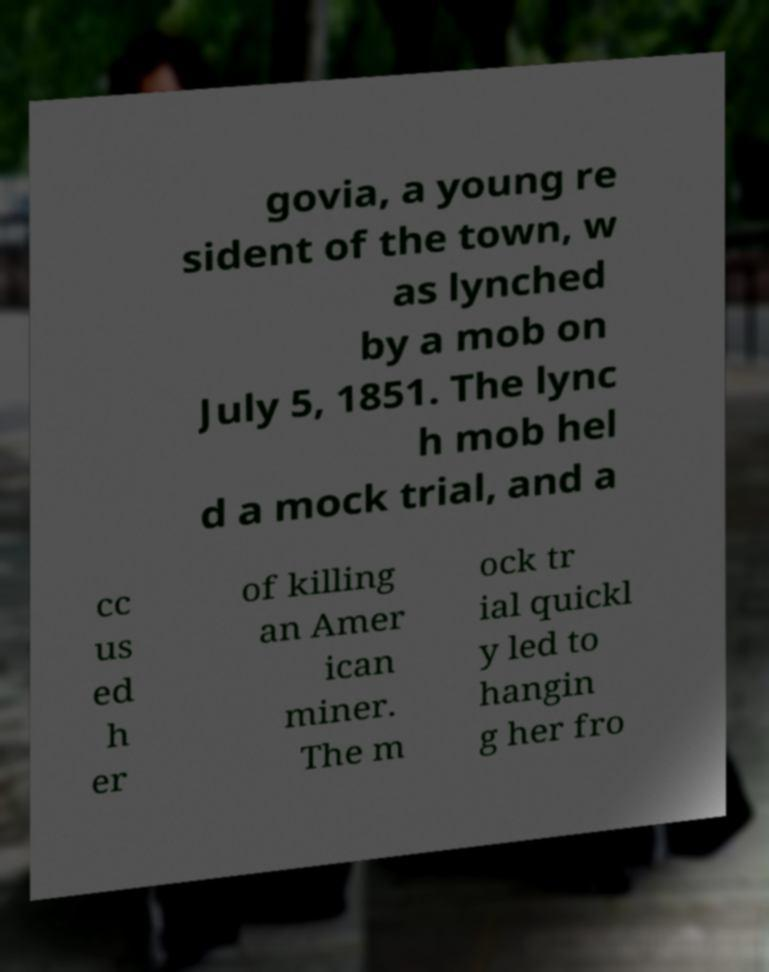Could you assist in decoding the text presented in this image and type it out clearly? govia, a young re sident of the town, w as lynched by a mob on July 5, 1851. The lync h mob hel d a mock trial, and a cc us ed h er of killing an Amer ican miner. The m ock tr ial quickl y led to hangin g her fro 